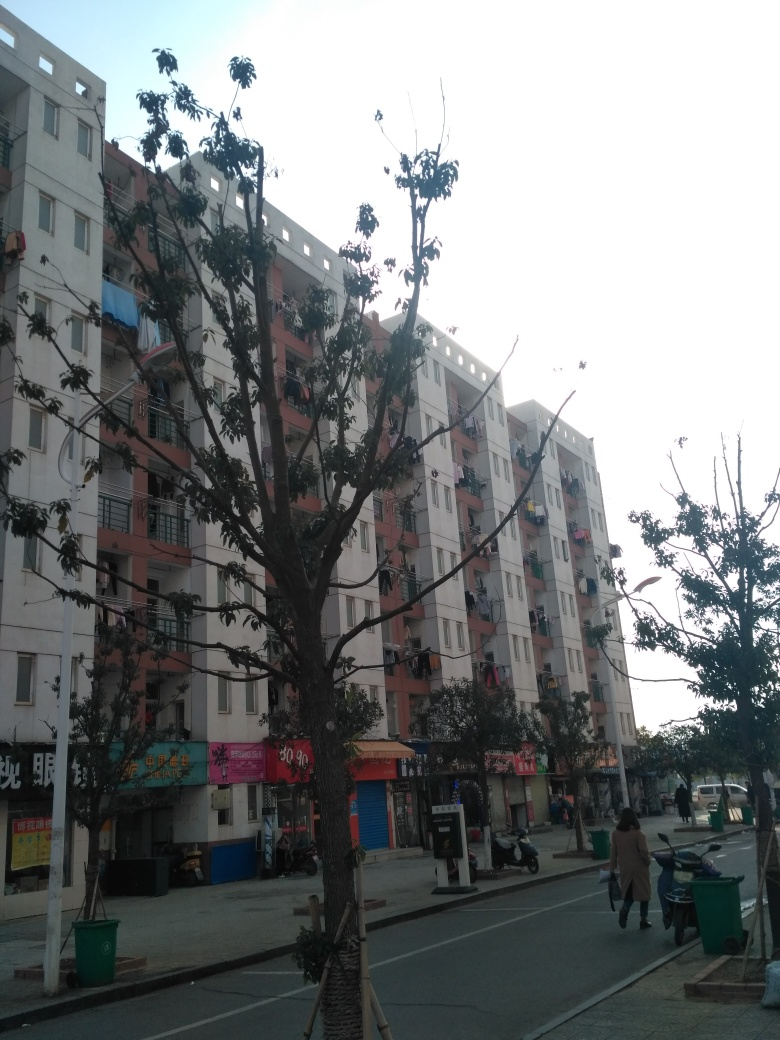What can you infer about the lifestyle of people living in this area? From the image, one could infer that the lifestyle in this area is likely quite urban and community-oriented. The ground-floor shops imply a convenience for local residents to access goods and services. The presence of on-street parking and a clear pedestrian sidewalk suggest that residents might use a mix of transportation methods. The modest size of the balconies and the practical architecture indicate that this may be a working-class or middle-income neighborhood. 